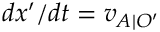Convert formula to latex. <formula><loc_0><loc_0><loc_500><loc_500>d x ^ { \prime } / d t = v _ { A | O ^ { \prime } }</formula> 